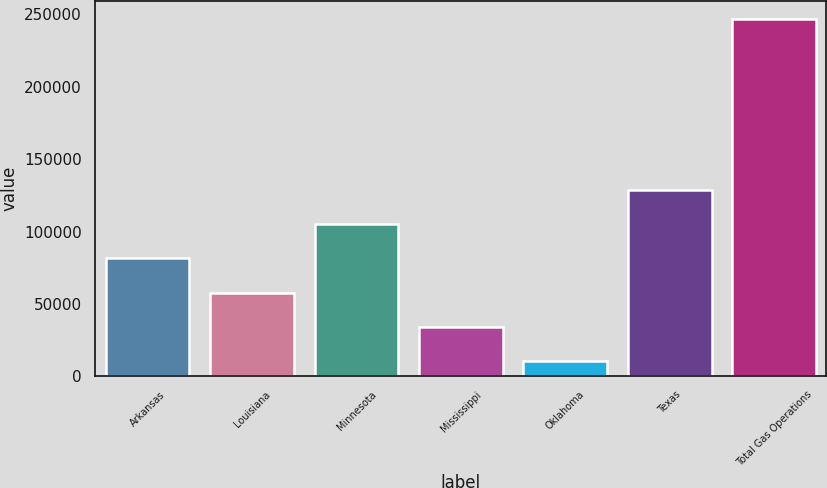Convert chart to OTSL. <chart><loc_0><loc_0><loc_500><loc_500><bar_chart><fcel>Arkansas<fcel>Louisiana<fcel>Minnesota<fcel>Mississippi<fcel>Oklahoma<fcel>Texas<fcel>Total Gas Operations<nl><fcel>81501.3<fcel>57874.2<fcel>105128<fcel>34247.1<fcel>10620<fcel>128756<fcel>246891<nl></chart> 